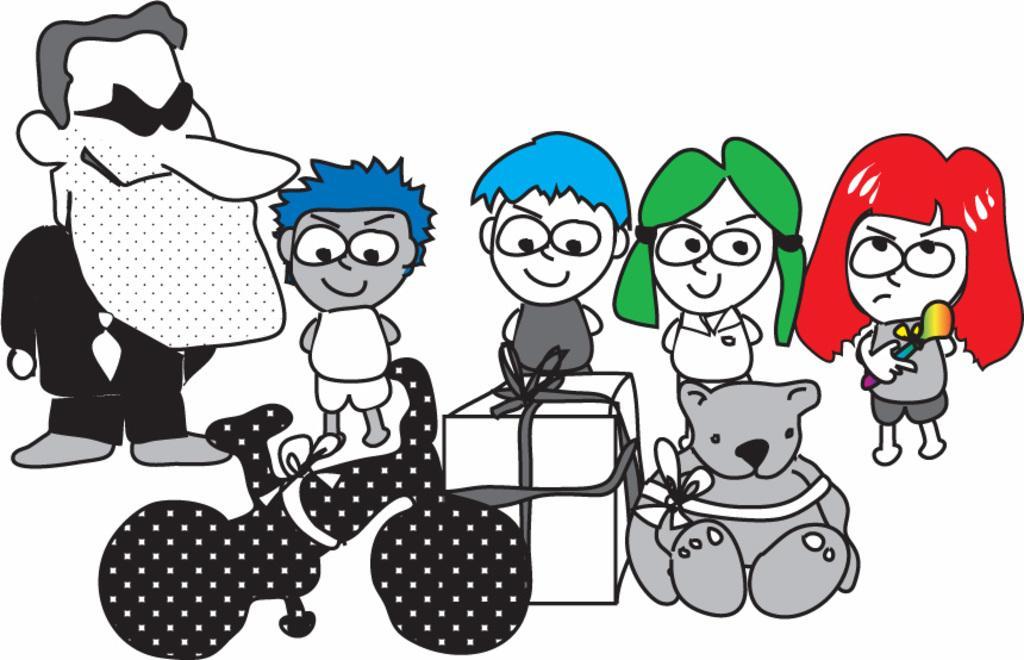Please provide a concise description of this image. In this image we can see cartoons. 